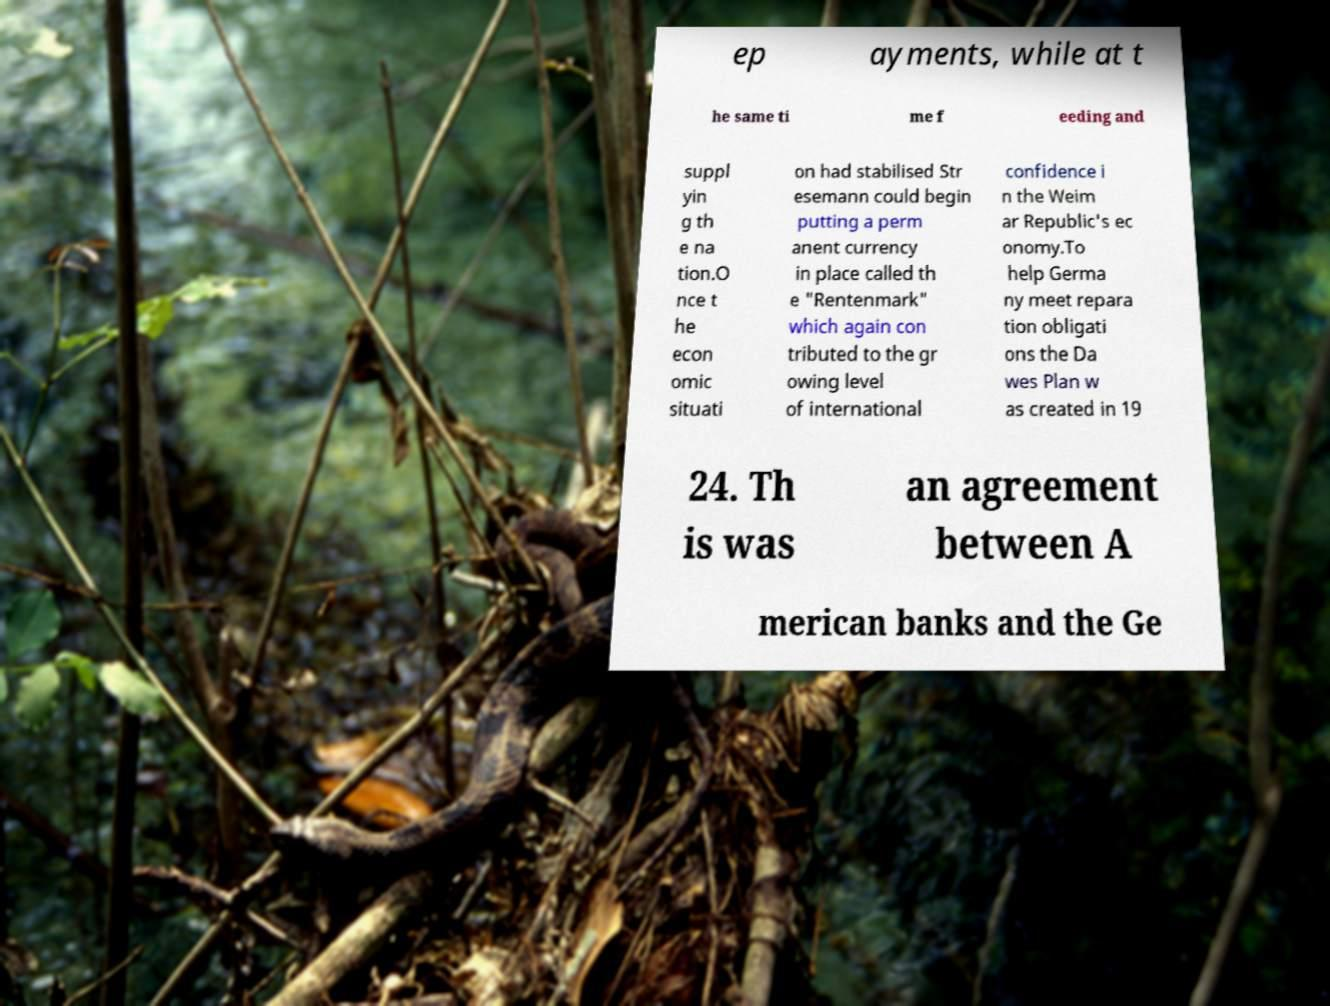Please read and relay the text visible in this image. What does it say? ep ayments, while at t he same ti me f eeding and suppl yin g th e na tion.O nce t he econ omic situati on had stabilised Str esemann could begin putting a perm anent currency in place called th e "Rentenmark" which again con tributed to the gr owing level of international confidence i n the Weim ar Republic's ec onomy.To help Germa ny meet repara tion obligati ons the Da wes Plan w as created in 19 24. Th is was an agreement between A merican banks and the Ge 